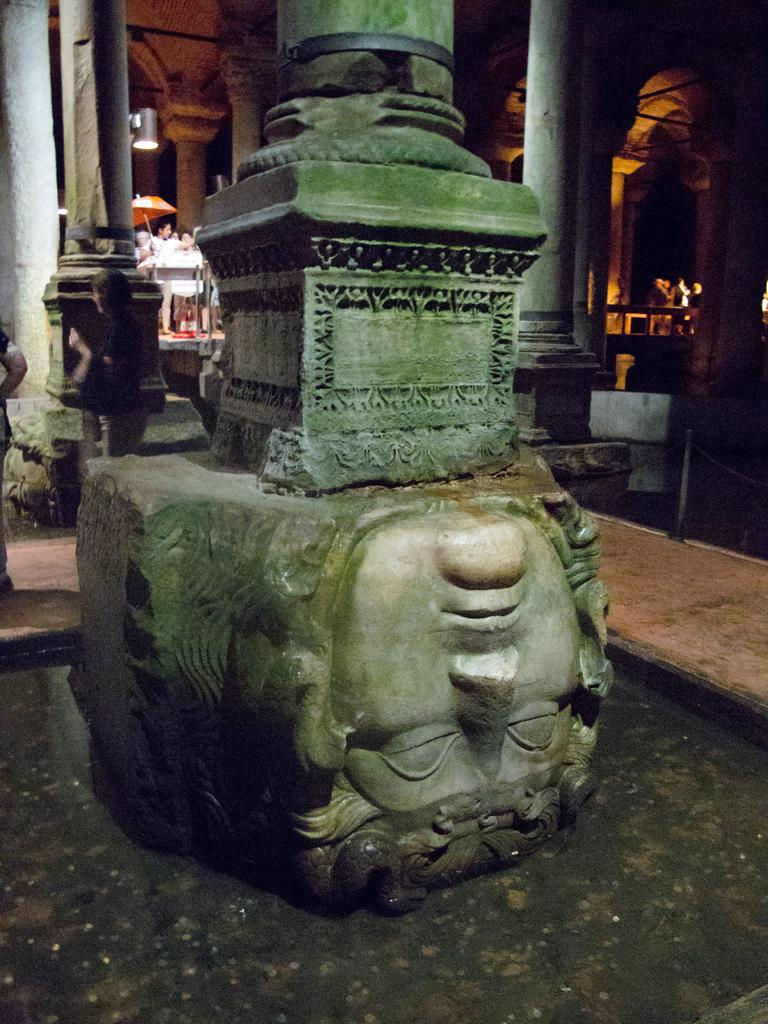What type of object is made of stone in the image? There is a carved stone in the image. What architectural features can be seen in the image? There are pillars and arches in the image. What is an object used for protection from the sun in the image? There is an umbrella in the image. Are there any people present in the image? Yes, there are people in the image. What other objects can be seen in the image? There are some objects in the image. What type of cord is being used to hold the act together in the image? There is no mention of a cord or an act in the image; it features a carved stone, pillars, an umbrella, people, arches, and other objects. 